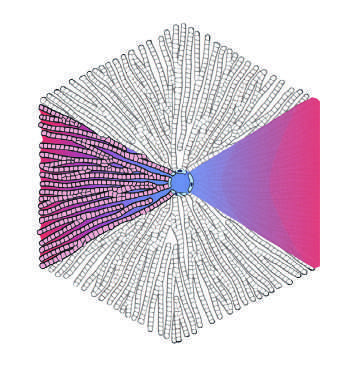s zone 3 the farthest?
Answer the question using a single word or phrase. Yes 